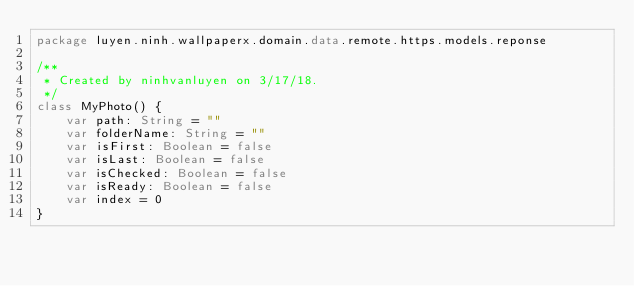Convert code to text. <code><loc_0><loc_0><loc_500><loc_500><_Kotlin_>package luyen.ninh.wallpaperx.domain.data.remote.https.models.reponse

/**
 * Created by ninhvanluyen on 3/17/18.
 */
class MyPhoto() {
    var path: String = ""
    var folderName: String = ""
    var isFirst: Boolean = false
    var isLast: Boolean = false
    var isChecked: Boolean = false
    var isReady: Boolean = false
    var index = 0
}</code> 